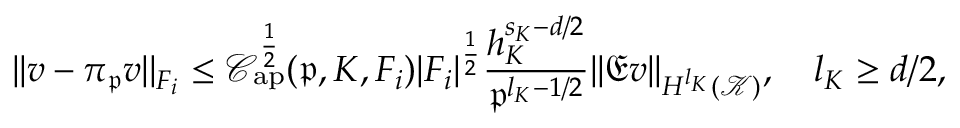Convert formula to latex. <formula><loc_0><loc_0><loc_500><loc_500>| | v - \pi _ { \mathfrak { p } } v | | _ { F _ { i } } \leq \mathcal { C } _ { a p } ^ { \frac { 1 } { 2 } } ( \mathfrak { p } , K , F _ { i } ) | F _ { i } | ^ { \frac { 1 } { 2 } } \frac { h _ { K } ^ { s _ { K } - d / 2 } } { \mathfrak { p } ^ { l _ { K } - 1 / 2 } } | | \mathfrak { E } v | | _ { H ^ { l _ { K } } ( \mathcal { K } ) } , \quad l _ { K } \geq d / 2 ,</formula> 